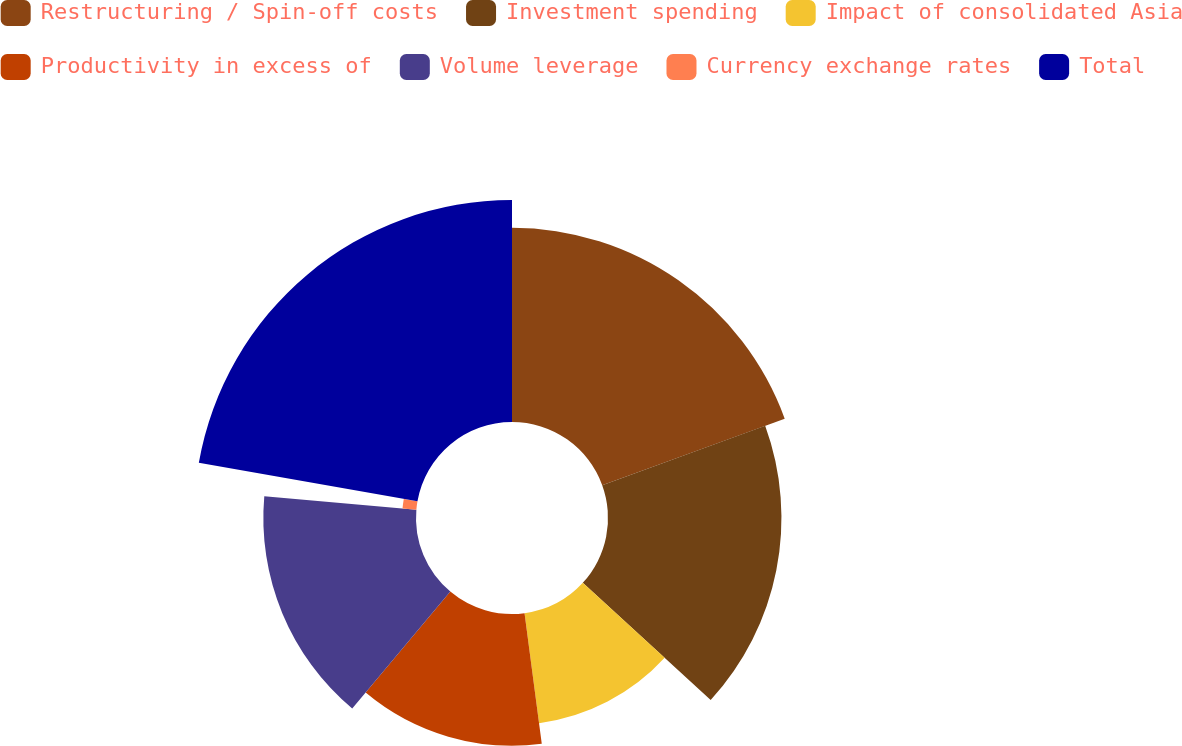<chart> <loc_0><loc_0><loc_500><loc_500><pie_chart><fcel>Restructuring / Spin-off costs<fcel>Investment spending<fcel>Impact of consolidated Asia<fcel>Productivity in excess of<fcel>Volume leverage<fcel>Currency exchange rates<fcel>Total<nl><fcel>19.44%<fcel>17.36%<fcel>11.11%<fcel>13.19%<fcel>15.28%<fcel>1.39%<fcel>22.22%<nl></chart> 